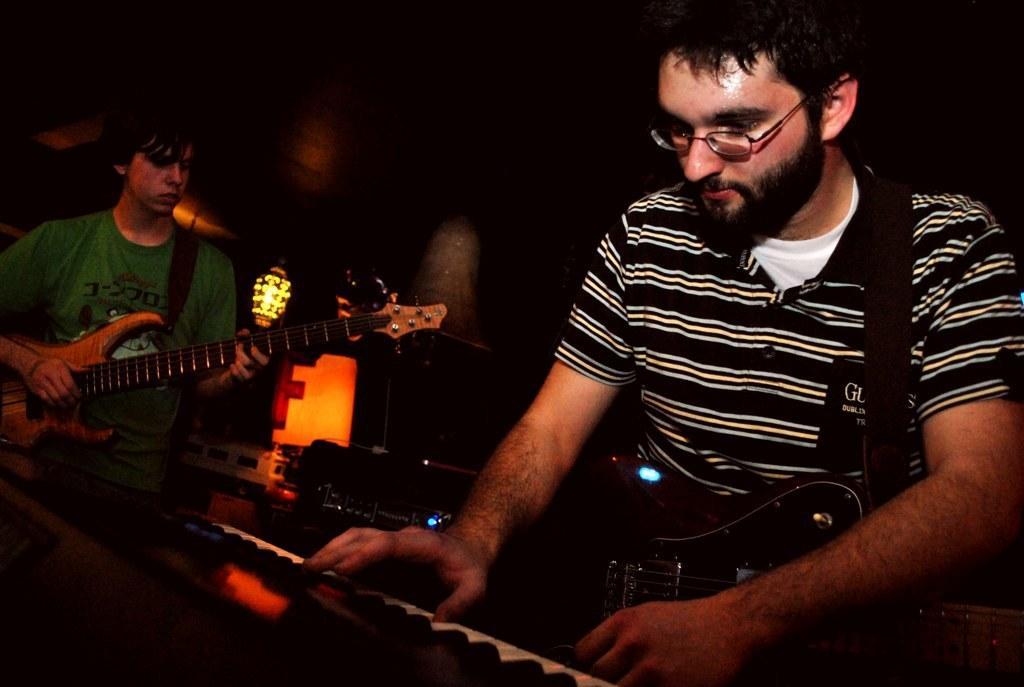In one or two sentences, can you explain what this image depicts? Here we can see a person on the right side. He is holding a guitar and he is playing a piano. There is a person on the left side and he is playing a guitar. 